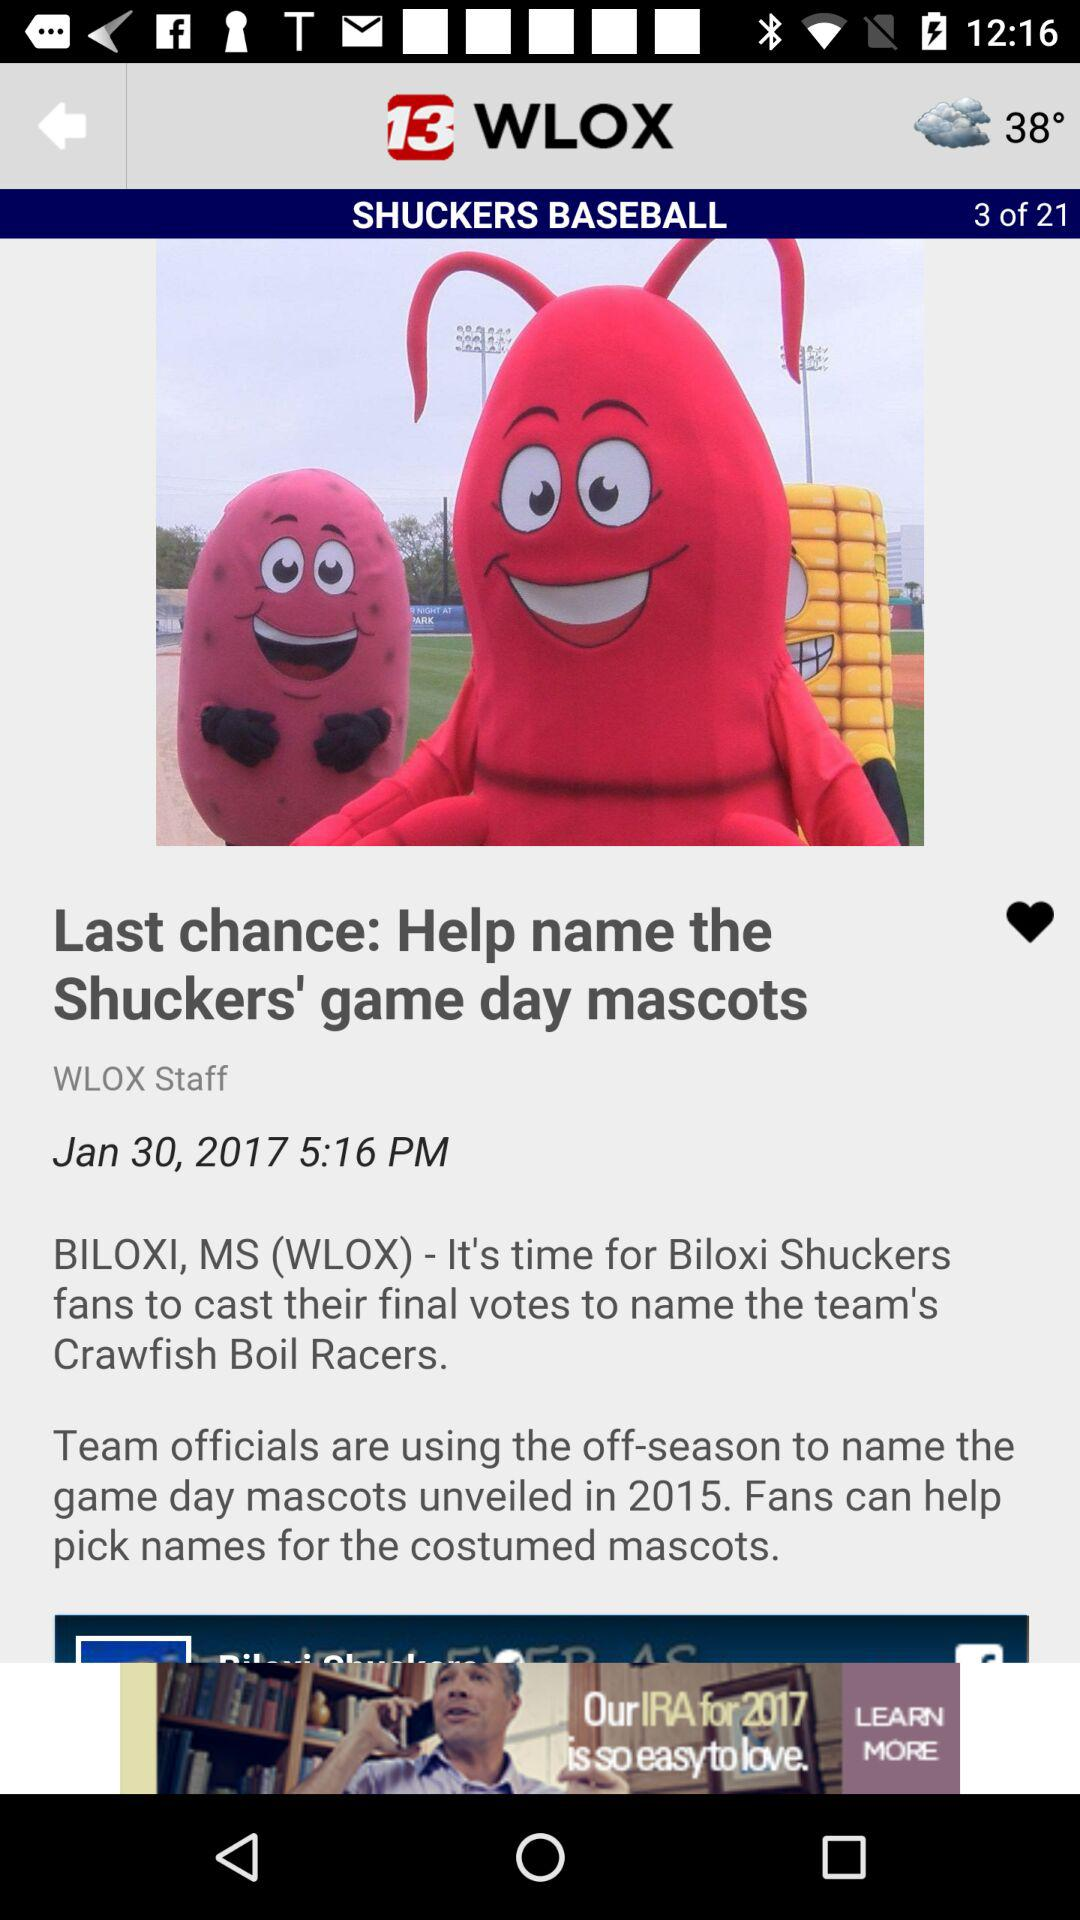What is the temperature? The temperature is 38°. 